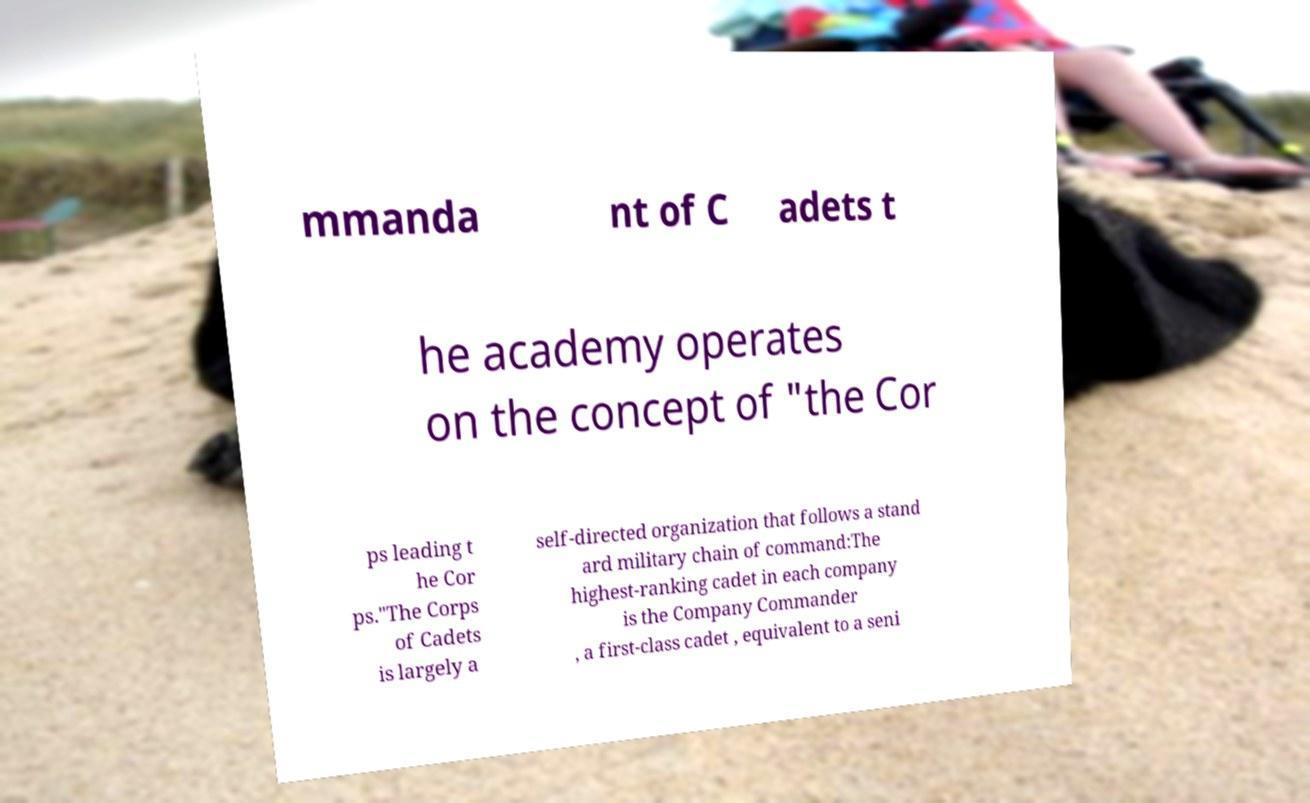Please read and relay the text visible in this image. What does it say? mmanda nt of C adets t he academy operates on the concept of "the Cor ps leading t he Cor ps."The Corps of Cadets is largely a self-directed organization that follows a stand ard military chain of command:The highest-ranking cadet in each company is the Company Commander , a first-class cadet , equivalent to a seni 